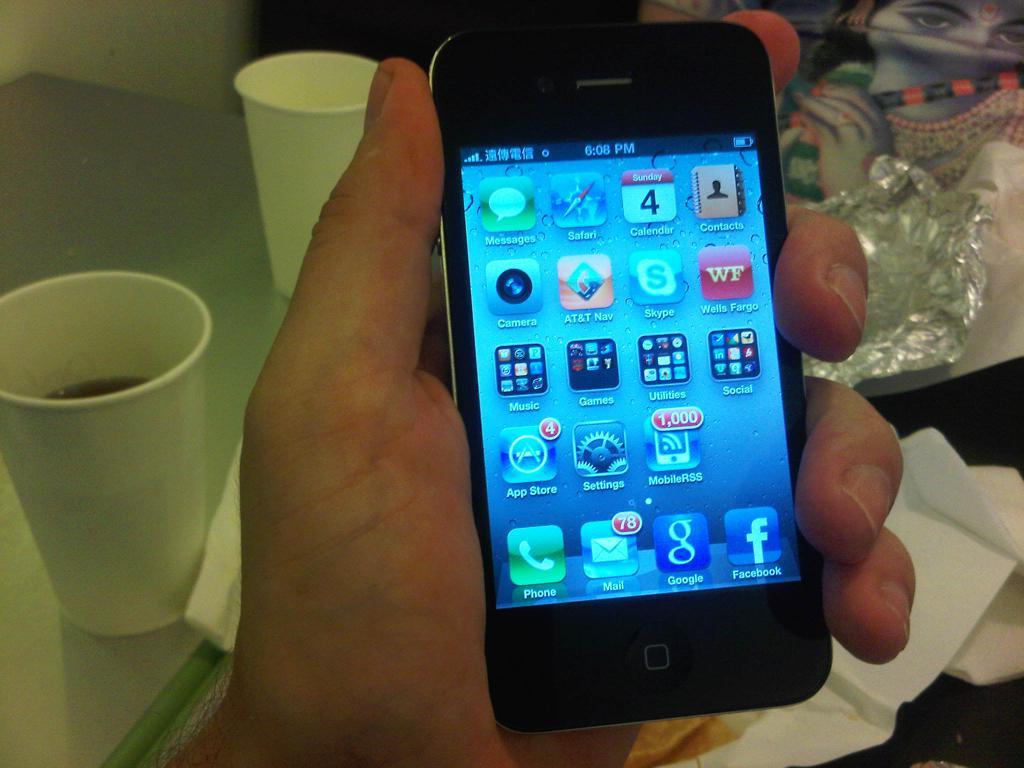What is the number in the calendar app?
Offer a terse response. 4. What social media app is on the bottom right of this phone?
Your answer should be compact. Facebook. 